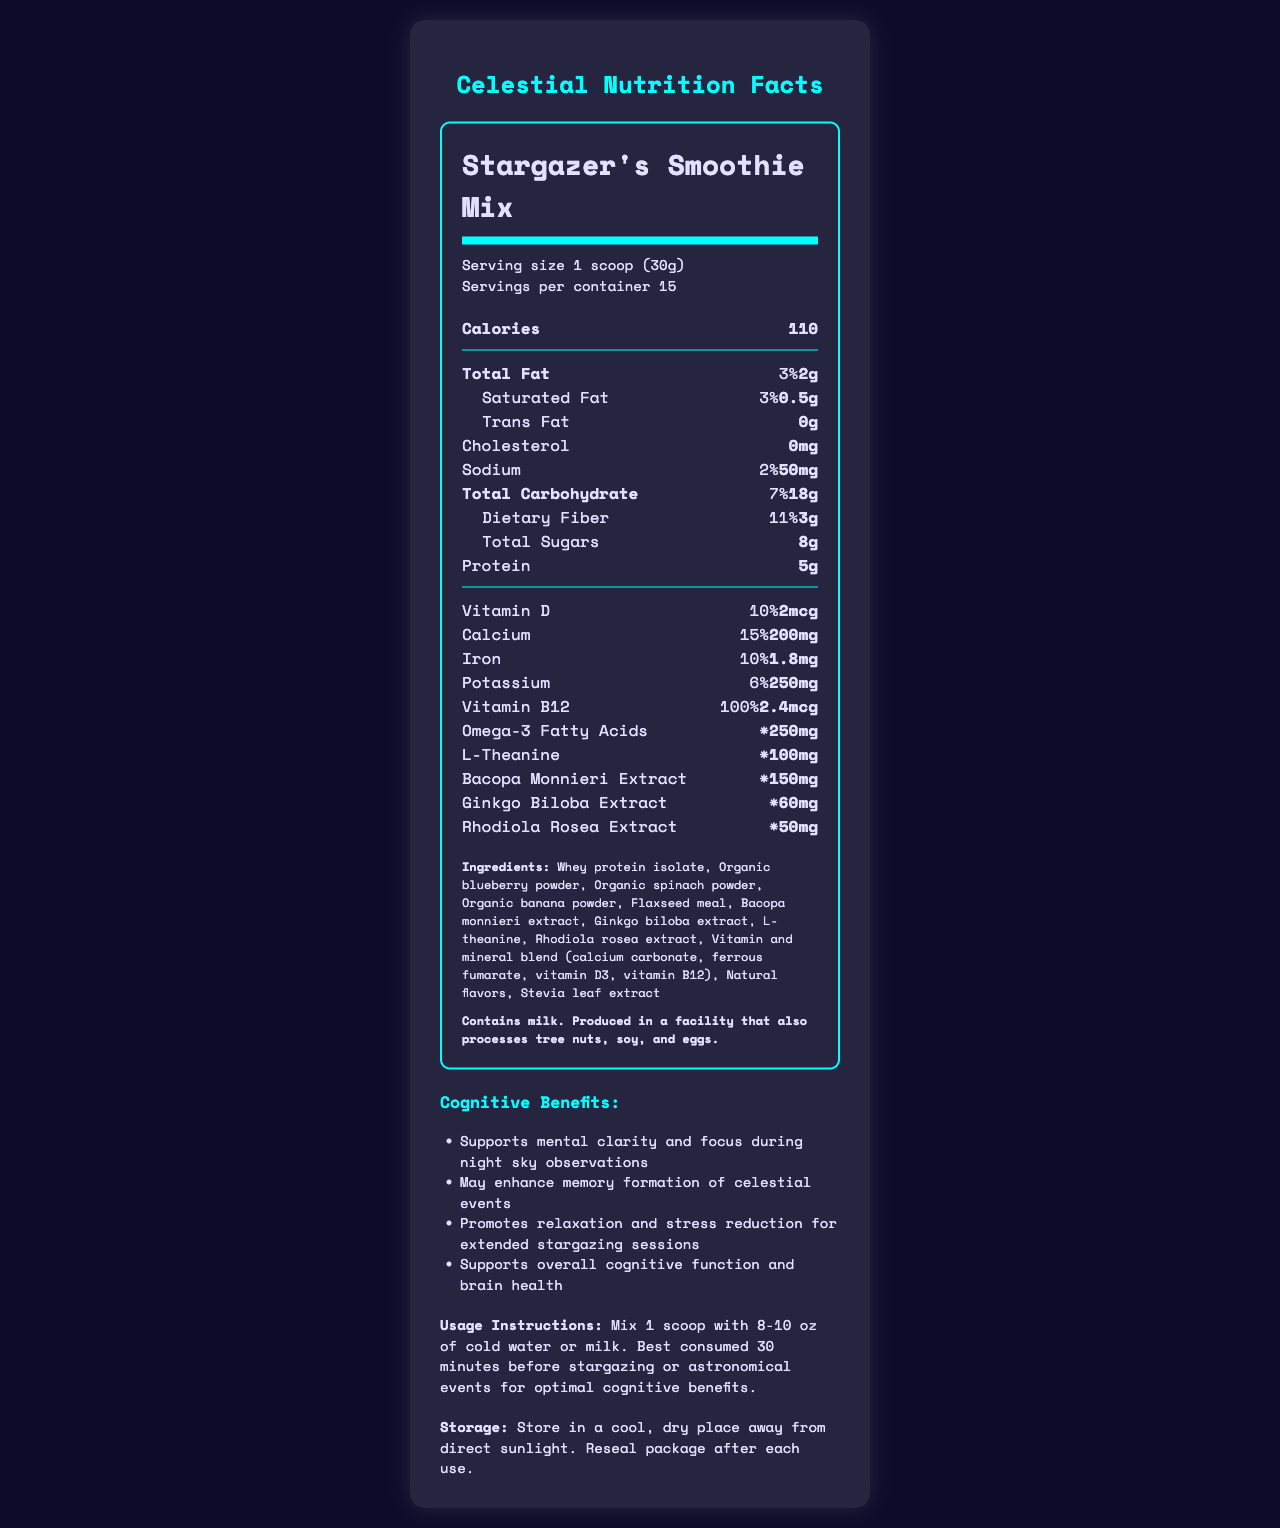what is the serving size of Stargazer's Smoothie Mix? The serving size is explicitly mentioned in the document under the section "Serving size".
Answer: 1 scoop (30g) how many servings are there per container? The number of servings per container is stated in the document under "Servings per container".
Answer: 15 how many calories does one serving of this smoothie mix have? The calorie content per serving is provided in the document under "Calories".
Answer: 110 calories list three cognitive-enhancing nutrients in this smoothie mix. These ingredients are listed under the nutritional information section, each associated with cognitive benefits.
Answer: L-Theanine, Bacopa Monnieri Extract, Ginkgo Biloba Extract what amount of vitamin B12 is in one serving of the smoothie mix? The amount of Vitamin B12 per serving is listed along with its daily value percentage.
Answer: 2.4 mcg how much total fat is there in one serving? A. 0.5g B. 2g C. 5g D. 8g The document states that there is 2g of total fat per serving, located under the "Total Fat" section.
Answer: B. 2g which of the following is a benefit mentioned in the document? I. Supports mental clarity and focus II. Increases muscle mass III. Enhances vision A. I only B. I and III C. II and III The benefits section explicitly mentions "Supports mental clarity and focus during night sky observations" while the other options are not mentioned.
Answer: A. I only is the smoothie mix suitable for individuals with milk allergies? The allergen information states that the product contains milk.
Answer: No describe the main cognitive benefits of the Stargazer's Smoothie Mix. The document lists these cognitive benefits under the section "Cognitive Benefits".
Answer: Supports mental clarity and focus during night sky observations, may enhance memory formation of celestial events, promotes relaxation and stress reduction for extended stargazing sessions, and supports overall cognitive function and brain health. is the daily value percentage of omega-3 fatty acids provided in the document? The document uses an asterisk (*) to indicate that the daily value percentage for omega-3 fatty acids is not available.
Answer: No how many mg of sodium does one serving contain? The amount of sodium per serving is listed under the "Sodium" section.
Answer: 50mg what is the storage recommendation for Stargazer's Smoothie Mix? The storage instructions are provided at the bottom of the document in the "Storage" section.
Answer: Store in a cool, dry place away from direct sunlight. Reseal package after each use. who is the intended target audience for consuming this product? The product is tailored with cognitive-enhancing nutrients that support activities like stargazing and astronomical observations, as indicated by the cognitive benefits and usage instructions.
Answer: Stargazers and people observing astronomical events what are the listed ingredients of the smoothie mix? These are listed under the "Ingredients" section in the document.
Answer: Whey protein isolate, Organic blueberry powder, Organic spinach powder, Organic banana powder, Flaxseed meal, Bacopa monnieri extract, Ginkgo biloba extract, L-theanine, Rhodiola rosea extract, Vitamin and mineral blend (calcium carbonate, ferrous fumarate, vitamin D3, vitamin B12), Natural flavors, Stevia leaf extract how many grams of protein are in one serving? The document lists 5 grams of protein per serving under the "Protein" section.
Answer: 5g what time before stargazing is recommended to consume the smoothie for optimal cognitive benefits? The usage instructions recommend consuming the smoothie mix 30 minutes before stargazing or astronomical events for optimal cognitive benefits.
Answer: 30 minutes what percentage of the Daily Value does the calcium content in one serving represent? The document states that there is 15% of the daily value of calcium per serving.
Answer: 15% how many grams of dietary fiber are in one serving? The document lists 3 grams of dietary fiber per serving under the "Dietary Fiber" section.
Answer: 3g are the total carbohydrate and dietary fiber amounts in the smoothie mix listed in grams or milligrams? Both the total carbohydrate and dietary fiber amounts are listed in grams under their respective sections in the document.
Answer: Grams (g) how much rhodiola rosea extract is in one serving? The document specifically lists 50mg of Rhodiola Rosea Extract per serving.
Answer: 50mg 